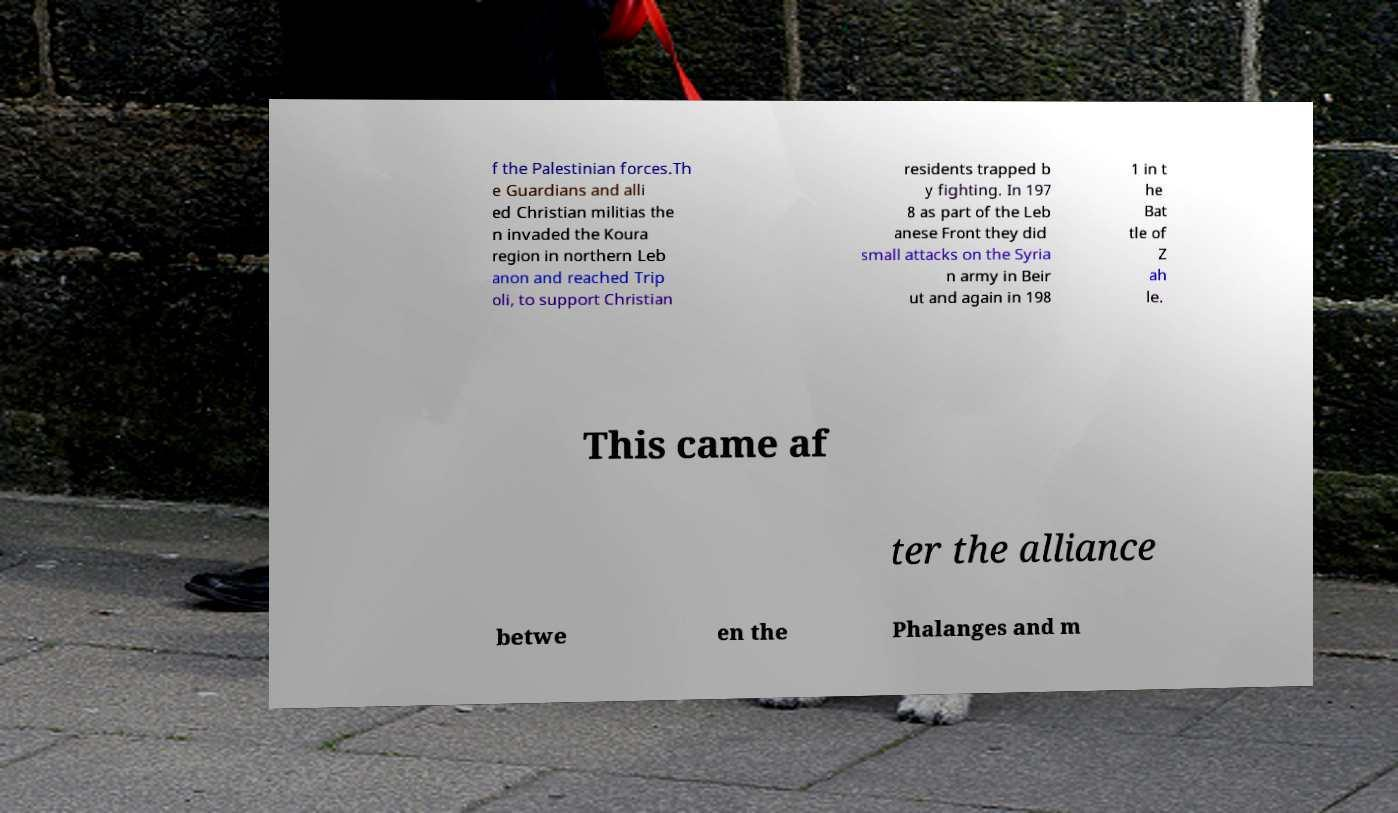What messages or text are displayed in this image? I need them in a readable, typed format. f the Palestinian forces.Th e Guardians and alli ed Christian militias the n invaded the Koura region in northern Leb anon and reached Trip oli, to support Christian residents trapped b y fighting. In 197 8 as part of the Leb anese Front they did small attacks on the Syria n army in Beir ut and again in 198 1 in t he Bat tle of Z ah le. This came af ter the alliance betwe en the Phalanges and m 